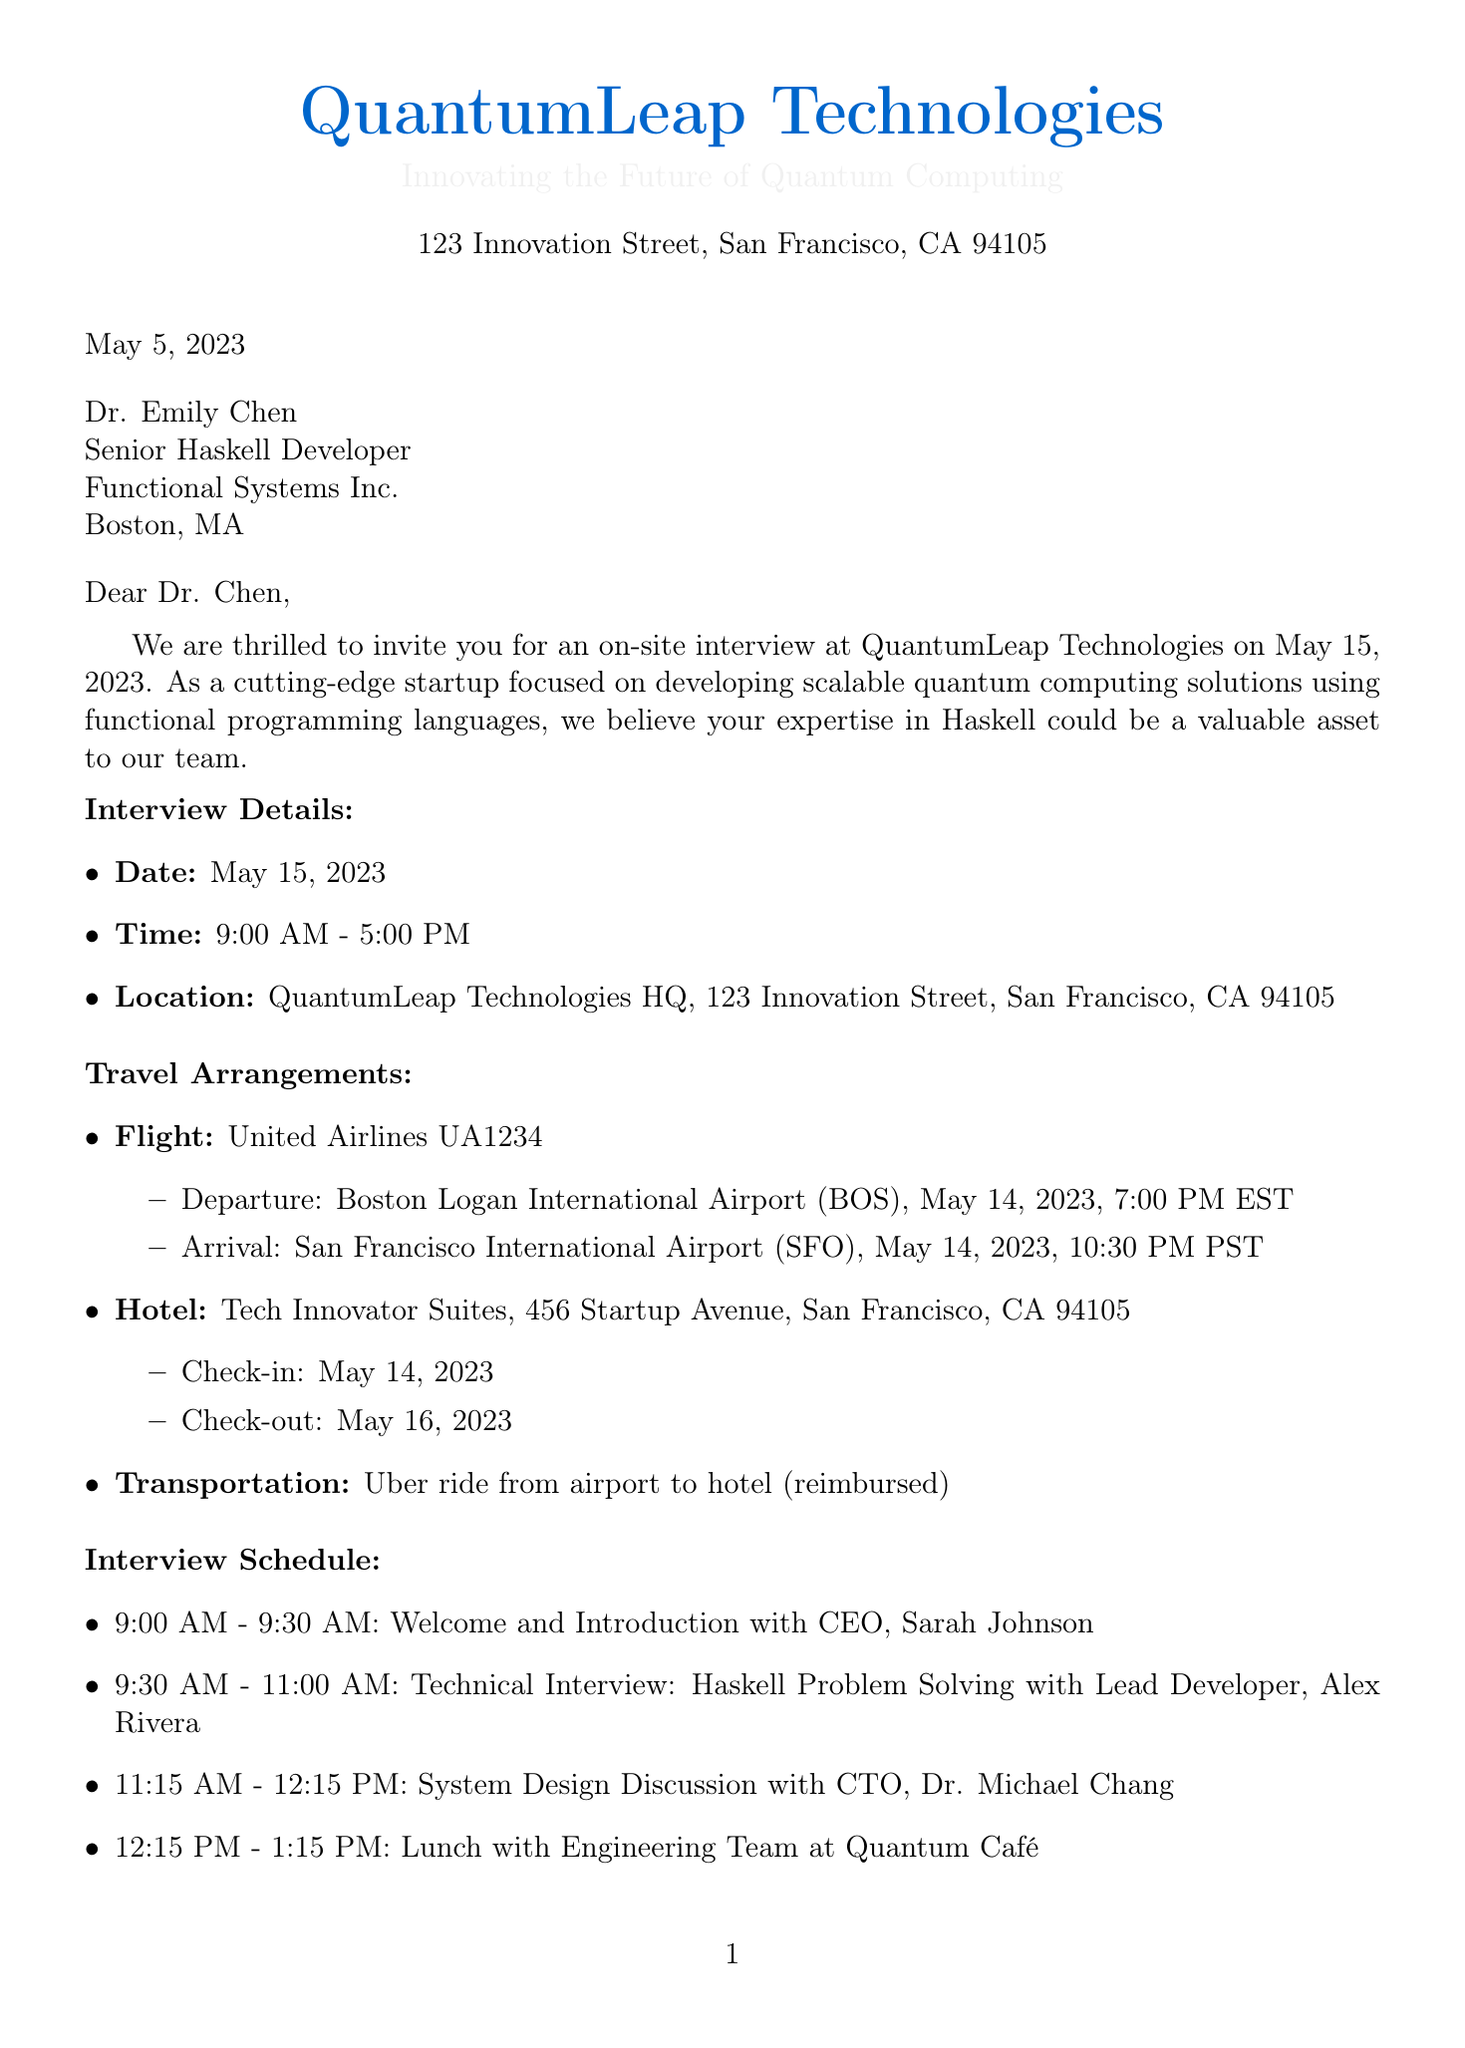What is the name of the company? The name of the company is provided in the introduction section of the document.
Answer: QuantumLeap Technologies When is the interview scheduled? The date of the interview is clearly stated in the interview details section.
Answer: May 15, 2023 What time does the interview start? The start time of the interview is specified in the interview details section.
Answer: 9:00 AM Who will conduct the technical interview? The name of the lead developer conducting the technical interview is mentioned.
Answer: Alex Rivera What is the dress code for the interview? The dress code is specified in the additional information section of the document.
Answer: Business casual What type of transportation is provided from the airport? The type of transportation for the candidate is mentioned in the travel arrangements section.
Answer: Uber ride What should the candidate bring to the interview? The required items for the candidate to bring are listed in the required items section.
Answer: Government-issued ID How long is the interview scheduled to last? The duration of the interview can be found in the interview details.
Answer: Full day (9:00 AM - 5:00 PM) Who is the recruiting coordinator? The contact person responsible for the recruitment process is mentioned at the end of the document.
Answer: Linda Martinez 